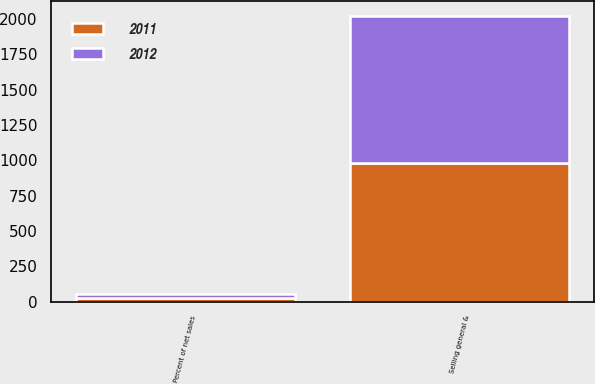<chart> <loc_0><loc_0><loc_500><loc_500><stacked_bar_chart><ecel><fcel>Selling general &<fcel>Percent of net sales<nl><fcel>2012<fcel>1039.5<fcel>25.9<nl><fcel>2011<fcel>982.2<fcel>26.6<nl></chart> 